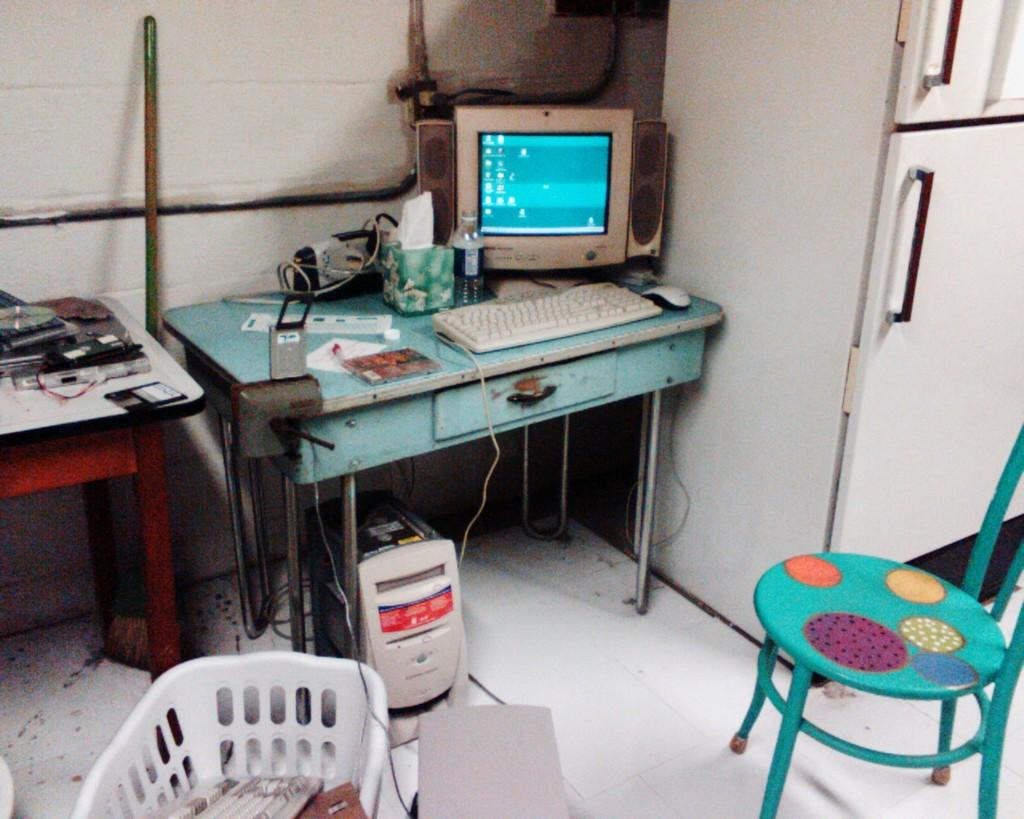What type of system is visible in the image? There is a system in the image, which typically refers to a computer system. What input device is present in the image? There is a keyboard in the image, which is commonly used for typing and inputting commands. What pointing device is present in the image? There is a mouse in the image, which is used for controlling the cursor on the screen. What beverage container is present in the image? There is a bottle in the image, which could contain water, soda, or other drinks. What type of furniture is present in the image? There are chairs in the image, which are used for sitting and provide comfort while using the computer system. What is the main processing unit of the computer system in the image? There is a CPU in the image, which stands for Central Processing Unit and is responsible for executing instructions and performing calculations. What large appliance is present in the image? There is a fridge in the image, which is used for storing and preserving food and beverages. What is the color of the surface on which objects are placed in the image? There are objects on a white color surface in the image, which provides a clean and neutral background for the computer system. What color sock is visible on the CPU in the image? There are no socks present in the image, as the CPU is an electronic component and does not have any clothing items associated with it. 